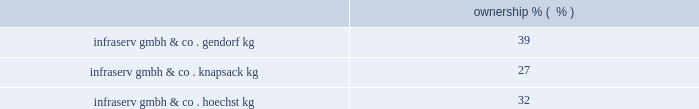Korea engineering plastics co. , ltd .
Founded in 1987 , kepco is the leading producer of pom in south korea .
Kepco is a venture between celanese's ticona business ( 50% ( 50 % ) ) , mitsubishi gas chemical company , inc .
( 40% ( 40 % ) ) and mitsubishi corporation ( 10% ( 10 % ) ) .
Kepco has polyacetal production facilities in ulsan , south korea , compounding facilities for pbt and nylon in pyongtaek , south korea , and participates with polyplastics and mitsubishi gas chemical company , inc .
In a world-scale pom facility in nantong , china .
Polyplastics co. , ltd .
Polyplastics is a leading supplier of engineered plastics in the asia-pacific region and is a venture between daicel chemical industries ltd. , japan ( 55% ( 55 % ) ) , and celanese's ticona business ( 45% ( 45 % ) ) .
Established in 1964 , polyplastics is a producer and marketer of pom and lcp in the asia-pacific region , with principal production facilities located in japan , taiwan , malaysia and china .
Fortron industries llc .
Fortron is a leading global producer of polyphenylene sulfide ( 201cpps 201d ) , sold under the fortron ae brand , which is used in a wide variety of automotive and other applications , especially those requiring heat and/or chemical resistance .
Established in 1992 , fortron is a limited liability company whose members are ticona fortron inc .
( 50% ( 50 % ) ownership and a wholly-owned subsidiary of cna holdings , llc ) and kureha corporation ( 50% ( 50 % ) ownership and a wholly-owned subsidiary of kureha chemical industry co. , ltd .
Of japan ) .
Fortron's facility is located in wilmington , north carolina .
This venture combines the sales , marketing , distribution , compounding and manufacturing expertise of celanese with the pps polymer technology expertise of kureha .
China acetate strategic ventures .
We hold an approximate 30% ( 30 % ) ownership interest in three separate acetate production ventures in china .
These include the nantong cellulose fibers co .
Ltd. , kunming cellulose fibers co .
Ltd .
And zhuhai cellulose fibers co .
Ltd .
The china national tobacco corporation , the chinese state-owned tobacco entity , controls the remaining ownership interest in each of these ventures .
With an estimated 30% ( 30 % ) share of the world's cigarette production and consumption , china is the world's largest and fastest growing area for acetate tow products according to the 2009 stanford research institute international chemical economics handbook .
Combined , these ventures are a leader in chinese domestic acetate production and are well positioned to supply chinese cigarette producers .
In december 2009 , we announced plans with china national tobacco to expand our acetate flake and tow capacity at our venture's nantong facility and we received formal approval for the expansions , each by 30000 tons , during 2010 .
Since their inception in 1986 , the china acetate ventures have completed 12 expansions , leading to earnings growth and increased dividends .
Our chinese acetate ventures fund their operations using operating cash flow .
During 2011 , we made contributions of $ 8 million related to the capacity expansions in nantong and have committed contributions of $ 9 million in 2012 .
In 2010 , we made contributions of $ 12 million .
Our chinese acetate ventures pay a dividend in the second quarter of each fiscal year , based on the ventures' performance for the preceding year .
In 2011 , 2010 and 2009 , we received cash dividends of $ 78 million , $ 71 million and $ 56 million , respectively .
Although our ownership interest in each of our china acetate ventures exceeds 20% ( 20 % ) , we account for these investments using the cost method of accounting because we determined that we cannot exercise significant influence over these entities due to local government investment in and influence over these entities , limitations on our involvement in the day-to-day operations and the present inability of the entities to provide timely financial information prepared in accordance with generally accepted accounting principles in the united states ( 201cus gaap 201d ) .
2022 other equity method investments infraservs .
We hold indirect ownership interests in several infraserv groups in germany that own and develop industrial parks and provide on-site general and administrative support to tenants .
The table below represents our equity investments in infraserv ventures as of december 31 , 2011: .

What is the growth rate in cash dividends received in 2011 compare to 2010? 
Computations: ((78 - 71) / 71)
Answer: 0.09859. 